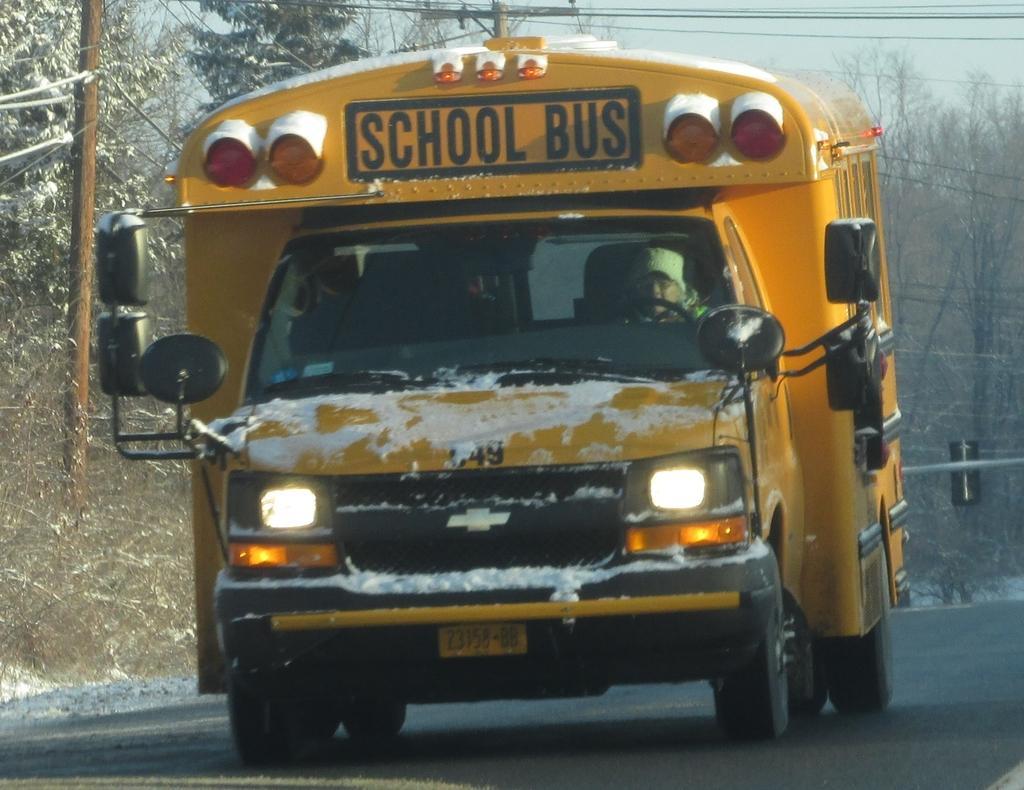Describe this image in one or two sentences. In this image there is a bus on a road, in the background there are trees, wires and poles. 